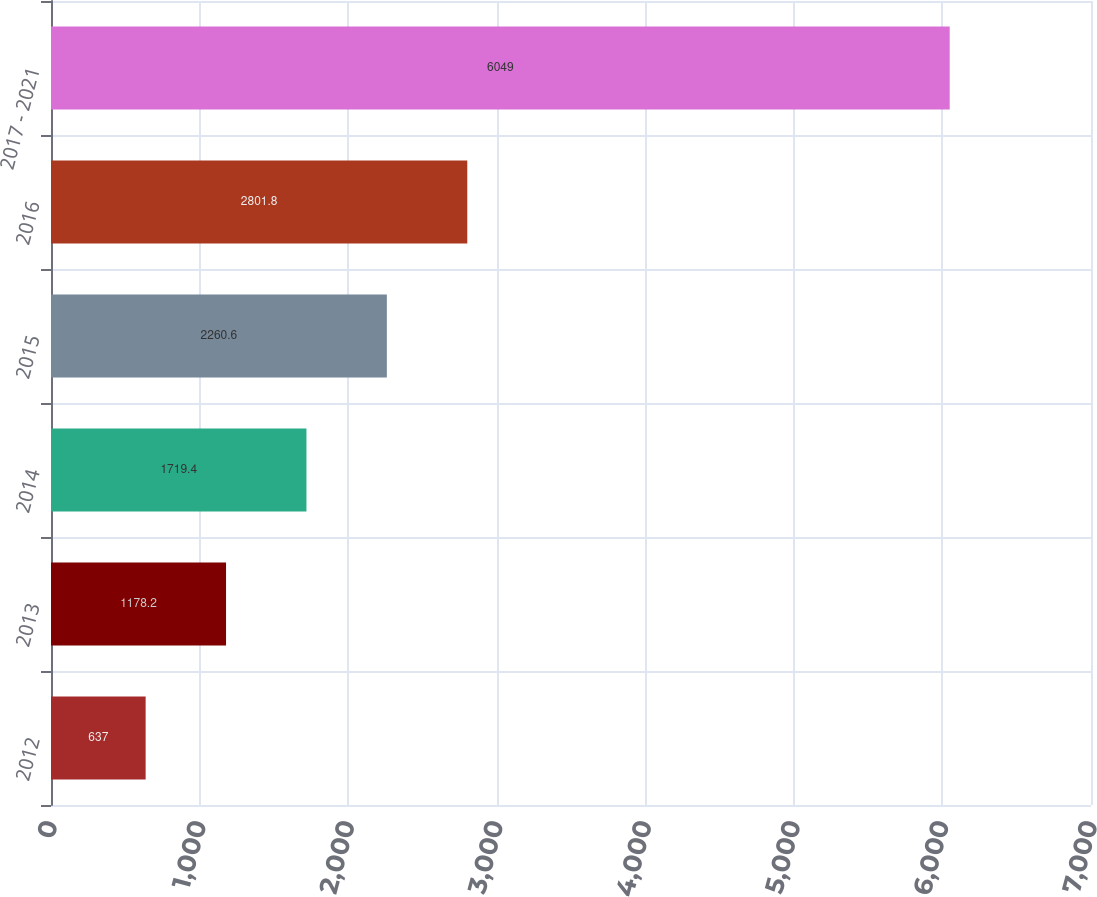<chart> <loc_0><loc_0><loc_500><loc_500><bar_chart><fcel>2012<fcel>2013<fcel>2014<fcel>2015<fcel>2016<fcel>2017 - 2021<nl><fcel>637<fcel>1178.2<fcel>1719.4<fcel>2260.6<fcel>2801.8<fcel>6049<nl></chart> 